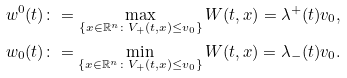<formula> <loc_0><loc_0><loc_500><loc_500>w ^ { 0 } ( t ) \colon = \max _ { \{ x \in \mathbb { R } ^ { n } \colon V _ { + } ( t , x ) \leq v _ { 0 } \} } W ( t , x ) = \lambda ^ { + } ( t ) v _ { 0 } , \\ w _ { 0 } ( t ) \colon = \min _ { \{ x \in \mathbb { R } ^ { n } \colon V _ { + } ( t , x ) \leq v _ { 0 } \} } W ( t , x ) = \lambda _ { - } ( t ) v _ { 0 } .</formula> 